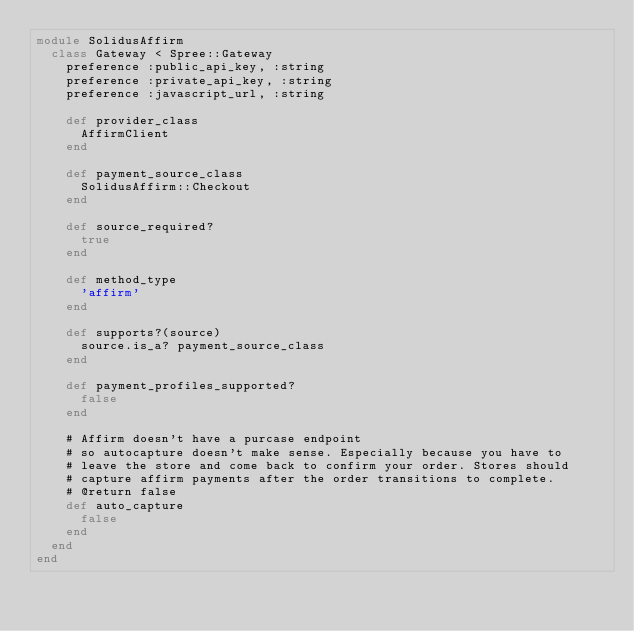Convert code to text. <code><loc_0><loc_0><loc_500><loc_500><_Ruby_>module SolidusAffirm
  class Gateway < Spree::Gateway
    preference :public_api_key, :string
    preference :private_api_key, :string
    preference :javascript_url, :string

    def provider_class
      AffirmClient
    end

    def payment_source_class
      SolidusAffirm::Checkout
    end

    def source_required?
      true
    end

    def method_type
      'affirm'
    end

    def supports?(source)
      source.is_a? payment_source_class
    end

    def payment_profiles_supported?
      false
    end

    # Affirm doesn't have a purcase endpoint
    # so autocapture doesn't make sense. Especially because you have to
    # leave the store and come back to confirm your order. Stores should
    # capture affirm payments after the order transitions to complete.
    # @return false
    def auto_capture
      false
    end
  end
end
</code> 